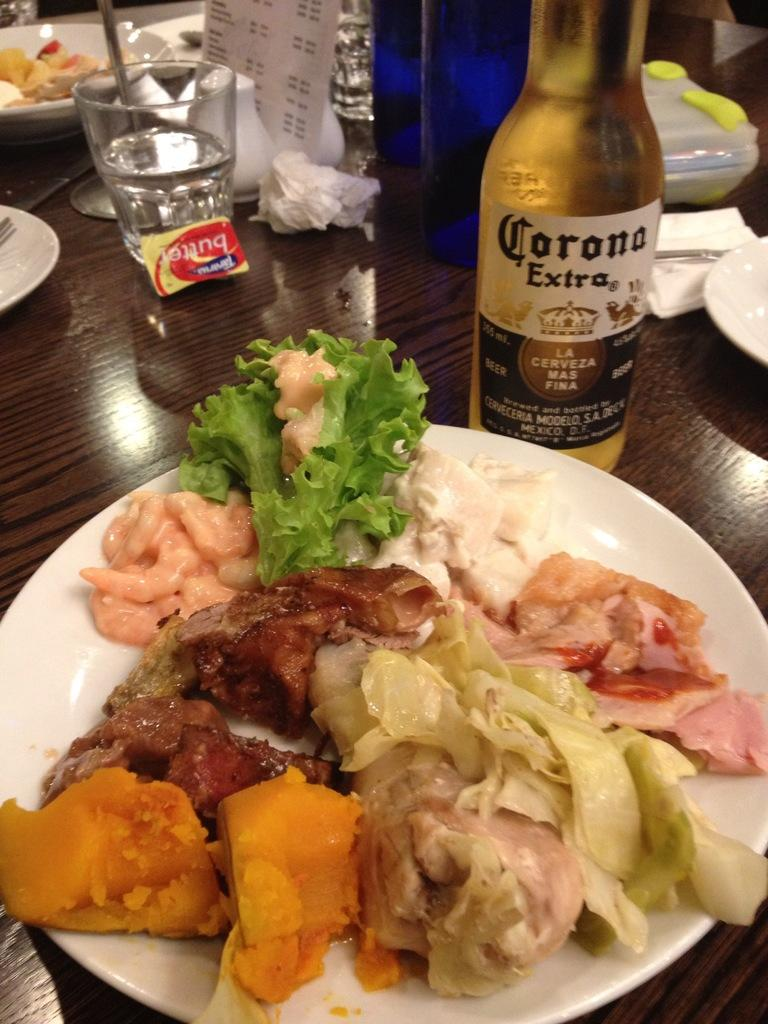<image>
Create a compact narrative representing the image presented. Plate with food including a bottle that says Corona on it. 